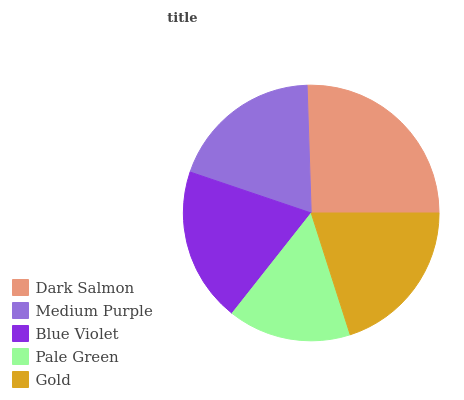Is Pale Green the minimum?
Answer yes or no. Yes. Is Dark Salmon the maximum?
Answer yes or no. Yes. Is Medium Purple the minimum?
Answer yes or no. No. Is Medium Purple the maximum?
Answer yes or no. No. Is Dark Salmon greater than Medium Purple?
Answer yes or no. Yes. Is Medium Purple less than Dark Salmon?
Answer yes or no. Yes. Is Medium Purple greater than Dark Salmon?
Answer yes or no. No. Is Dark Salmon less than Medium Purple?
Answer yes or no. No. Is Blue Violet the high median?
Answer yes or no. Yes. Is Blue Violet the low median?
Answer yes or no. Yes. Is Gold the high median?
Answer yes or no. No. Is Pale Green the low median?
Answer yes or no. No. 